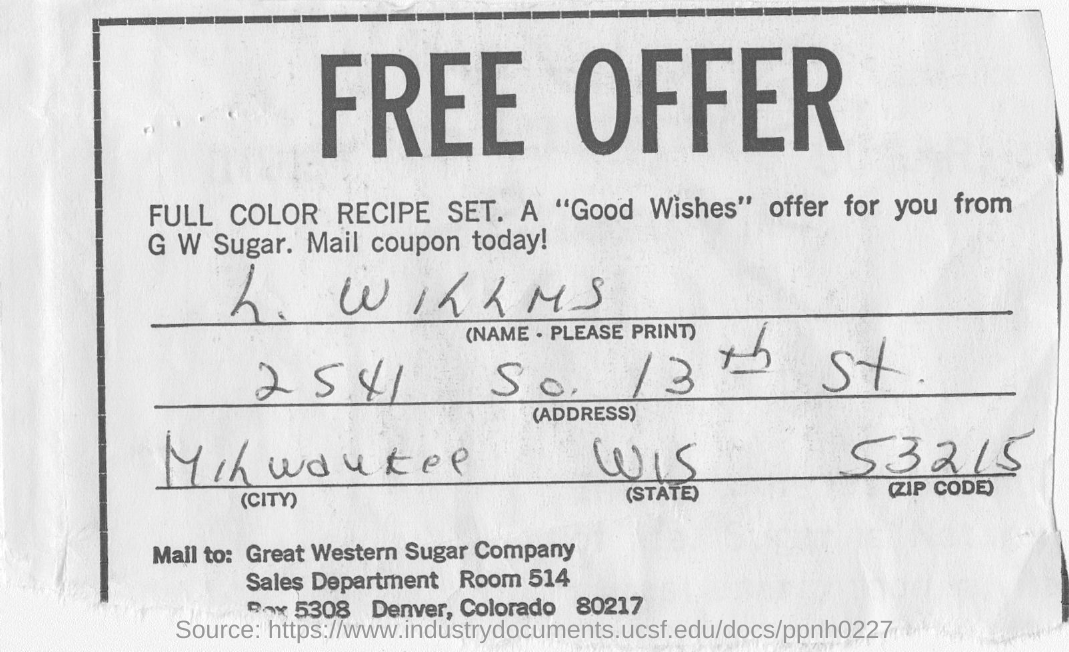Whose name is mentioned in the receipt?
Offer a very short reply. L. WILLMS. What is the Zip code mentioned in the receipt?
Your answer should be compact. 53215. To which company, the mail is to be send?
Offer a terse response. GREAT WESTERN SUGAR COMPANY. What is the address given in the receipt?
Offer a terse response. 2541 So. 13th st. 